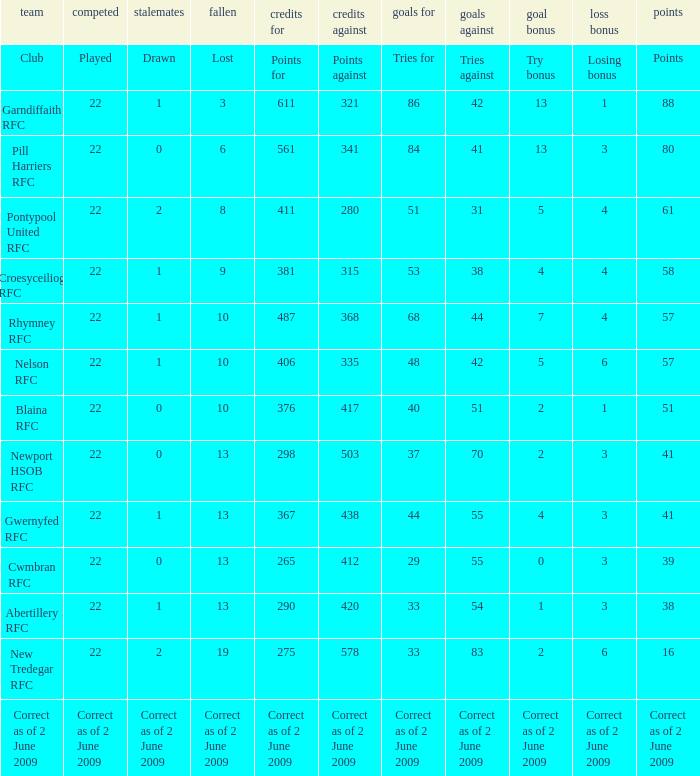Which club has 40 tries for? Blaina RFC. 